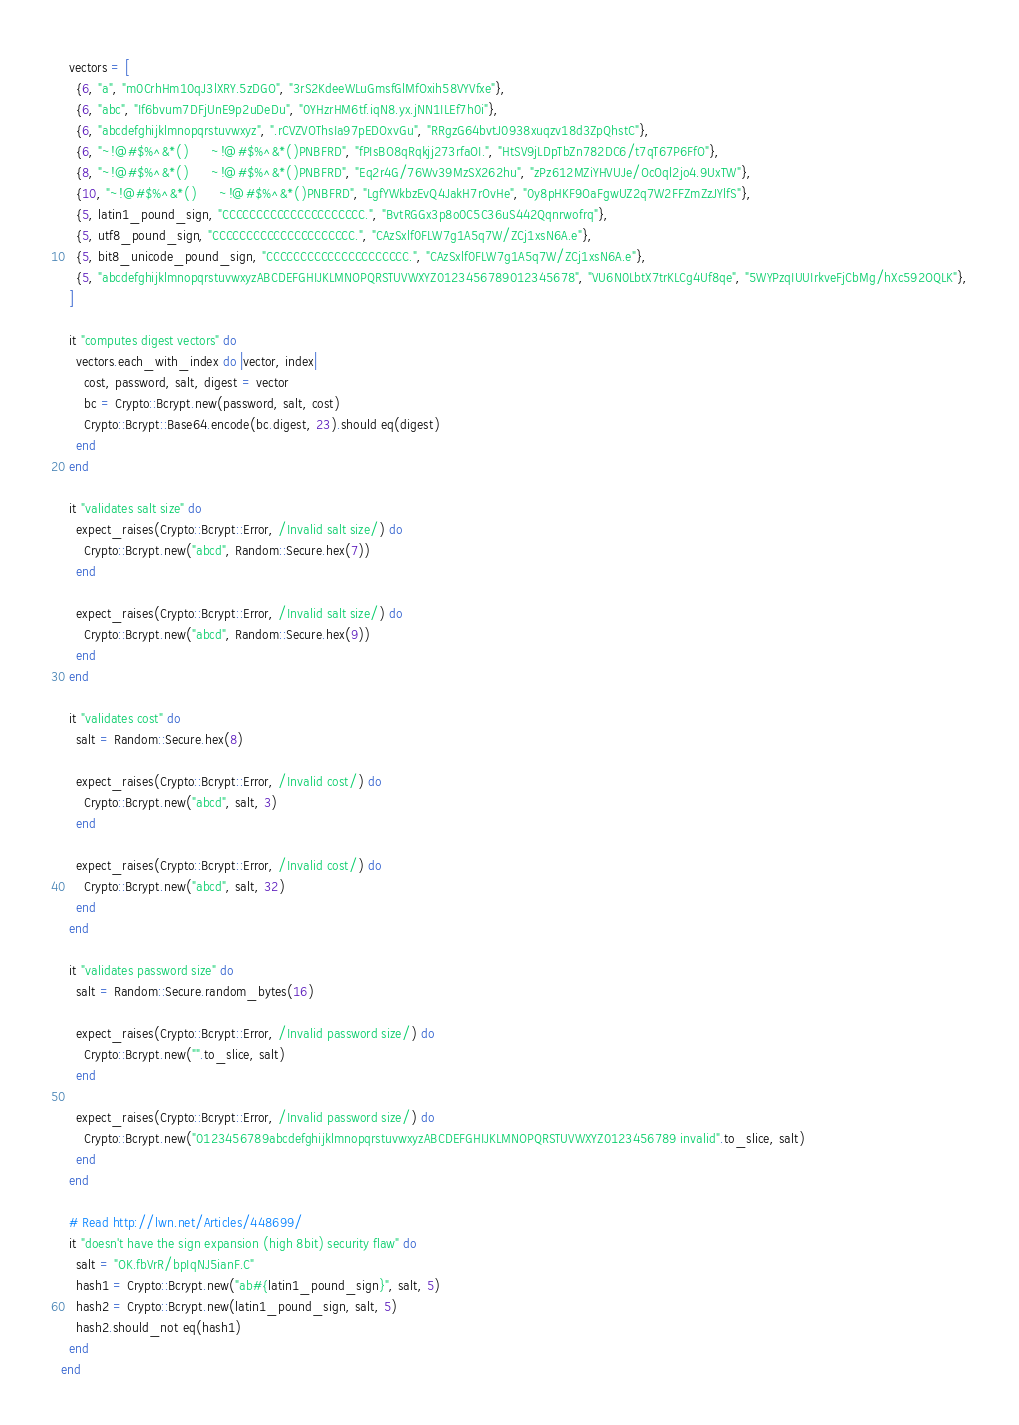<code> <loc_0><loc_0><loc_500><loc_500><_Crystal_>
  vectors = [
    {6, "a", "m0CrhHm10qJ3lXRY.5zDGO", "3rS2KdeeWLuGmsfGlMfOxih58VYVfxe"},
    {6, "abc", "If6bvum7DFjUnE9p2uDeDu", "0YHzrHM6tf.iqN8.yx.jNN1ILEf7h0i"},
    {6, "abcdefghijklmnopqrstuvwxyz", ".rCVZVOThsIa97pEDOxvGu", "RRgzG64bvtJ0938xuqzv18d3ZpQhstC"},
    {6, "~!@#$%^&*()      ~!@#$%^&*()PNBFRD", "fPIsBO8qRqkjj273rfaOI.", "HtSV9jLDpTbZn782DC6/t7qT67P6FfO"},
    {8, "~!@#$%^&*()      ~!@#$%^&*()PNBFRD", "Eq2r4G/76Wv39MzSX262hu", "zPz612MZiYHVUJe/OcOql2jo4.9UxTW"},
    {10, "~!@#$%^&*()      ~!@#$%^&*()PNBFRD", "LgfYWkbzEvQ4JakH7rOvHe", "0y8pHKF9OaFgwUZ2q7W2FFZmZzJYlfS"},
    {5, latin1_pound_sign, "CCCCCCCCCCCCCCCCCCCCC.", "BvtRGGx3p8o0C5C36uS442Qqnrwofrq"},
    {5, utf8_pound_sign, "CCCCCCCCCCCCCCCCCCCCC.", "CAzSxlf0FLW7g1A5q7W/ZCj1xsN6A.e"},
    {5, bit8_unicode_pound_sign, "CCCCCCCCCCCCCCCCCCCCC.", "CAzSxlf0FLW7g1A5q7W/ZCj1xsN6A.e"},
    {5, "abcdefghijklmnopqrstuvwxyzABCDEFGHIJKLMNOPQRSTUVWXYZ0123456789012345678", "VU6N0LbtX7trKLCg4Uf8qe", "5WYPzqIUUIrkveFjCbMg/hXc592OQLK"},
  ]

  it "computes digest vectors" do
    vectors.each_with_index do |vector, index|
      cost, password, salt, digest = vector
      bc = Crypto::Bcrypt.new(password, salt, cost)
      Crypto::Bcrypt::Base64.encode(bc.digest, 23).should eq(digest)
    end
  end

  it "validates salt size" do
    expect_raises(Crypto::Bcrypt::Error, /Invalid salt size/) do
      Crypto::Bcrypt.new("abcd", Random::Secure.hex(7))
    end

    expect_raises(Crypto::Bcrypt::Error, /Invalid salt size/) do
      Crypto::Bcrypt.new("abcd", Random::Secure.hex(9))
    end
  end

  it "validates cost" do
    salt = Random::Secure.hex(8)

    expect_raises(Crypto::Bcrypt::Error, /Invalid cost/) do
      Crypto::Bcrypt.new("abcd", salt, 3)
    end

    expect_raises(Crypto::Bcrypt::Error, /Invalid cost/) do
      Crypto::Bcrypt.new("abcd", salt, 32)
    end
  end

  it "validates password size" do
    salt = Random::Secure.random_bytes(16)

    expect_raises(Crypto::Bcrypt::Error, /Invalid password size/) do
      Crypto::Bcrypt.new("".to_slice, salt)
    end

    expect_raises(Crypto::Bcrypt::Error, /Invalid password size/) do
      Crypto::Bcrypt.new("0123456789abcdefghijklmnopqrstuvwxyzABCDEFGHIJKLMNOPQRSTUVWXYZ0123456789 invalid".to_slice, salt)
    end
  end

  # Read http://lwn.net/Articles/448699/
  it "doesn't have the sign expansion (high 8bit) security flaw" do
    salt = "OK.fbVrR/bpIqNJ5ianF.C"
    hash1 = Crypto::Bcrypt.new("ab#{latin1_pound_sign}", salt, 5)
    hash2 = Crypto::Bcrypt.new(latin1_pound_sign, salt, 5)
    hash2.should_not eq(hash1)
  end
end
</code> 